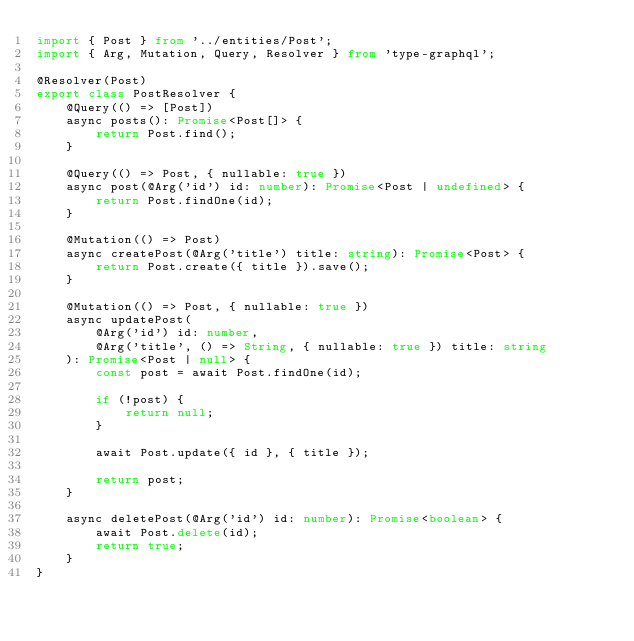<code> <loc_0><loc_0><loc_500><loc_500><_TypeScript_>import { Post } from '../entities/Post';
import { Arg, Mutation, Query, Resolver } from 'type-graphql';

@Resolver(Post)
export class PostResolver {
	@Query(() => [Post])
	async posts(): Promise<Post[]> {
		return Post.find();
	}

	@Query(() => Post, { nullable: true })
	async post(@Arg('id') id: number): Promise<Post | undefined> {
		return Post.findOne(id);
	}

	@Mutation(() => Post)
	async createPost(@Arg('title') title: string): Promise<Post> {
		return Post.create({ title }).save();
	}

	@Mutation(() => Post, { nullable: true })
	async updatePost(
		@Arg('id') id: number,
		@Arg('title', () => String, { nullable: true }) title: string
	): Promise<Post | null> {
		const post = await Post.findOne(id);

		if (!post) {
			return null;
		}

		await Post.update({ id }, { title });

		return post;
	}

	async deletePost(@Arg('id') id: number): Promise<boolean> {
		await Post.delete(id);
		return true;
	}
}
</code> 